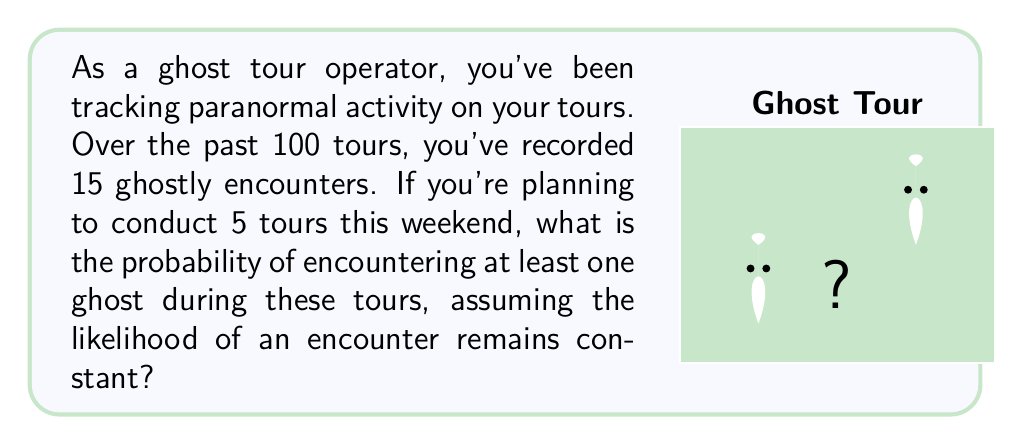Show me your answer to this math problem. Let's approach this step-by-step:

1) First, we need to calculate the probability of encountering a ghost on a single tour.
   $$P(\text{ghost on one tour}) = \frac{\text{number of tours with ghosts}}{\text{total number of tours}} = \frac{15}{100} = 0.15$$

2) Now, we need to find the probability of not encountering a ghost on a single tour.
   $$P(\text{no ghost on one tour}) = 1 - P(\text{ghost on one tour}) = 1 - 0.15 = 0.85$$

3) For 5 tours, the probability of not encountering any ghosts is:
   $$P(\text{no ghosts in 5 tours}) = (0.85)^5 \approx 0.4437$$

4) Therefore, the probability of encountering at least one ghost in 5 tours is:
   $$P(\text{at least one ghost in 5 tours}) = 1 - P(\text{no ghosts in 5 tours})$$
   $$= 1 - 0.4437 \approx 0.5563$$

5) Converting to a percentage:
   $$0.5563 \times 100\% \approx 55.63\%$$
Answer: $55.63\%$ 